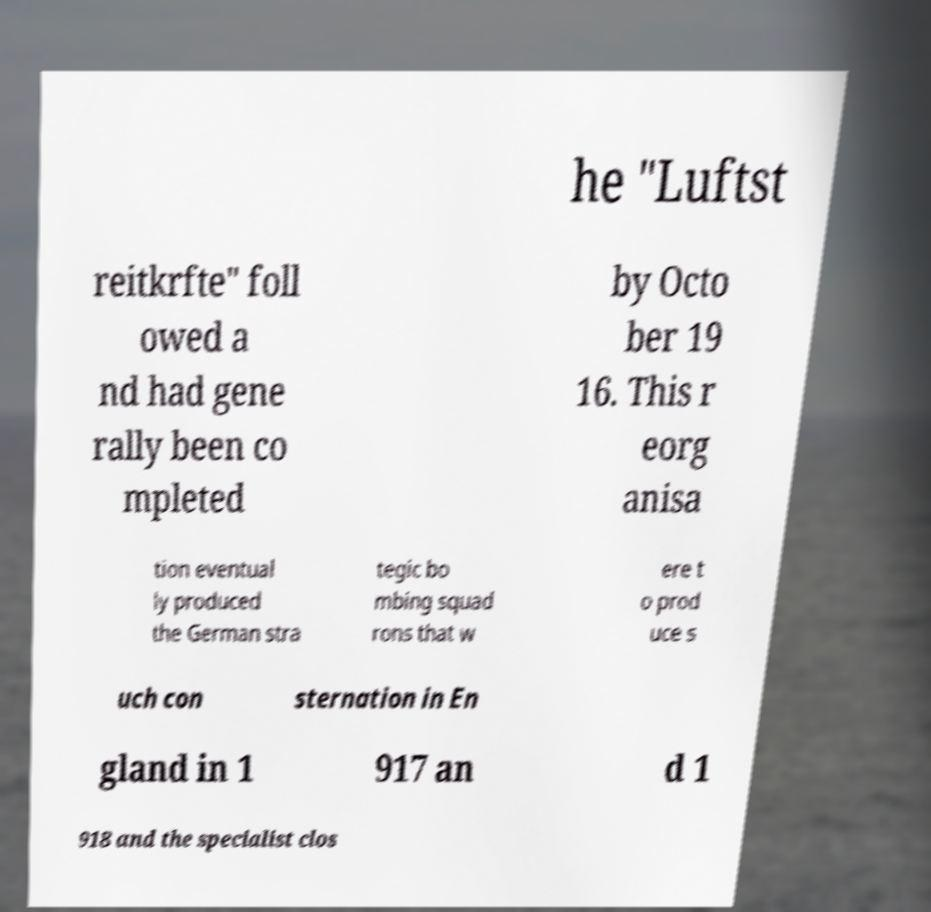Could you extract and type out the text from this image? he "Luftst reitkrfte" foll owed a nd had gene rally been co mpleted by Octo ber 19 16. This r eorg anisa tion eventual ly produced the German stra tegic bo mbing squad rons that w ere t o prod uce s uch con sternation in En gland in 1 917 an d 1 918 and the specialist clos 